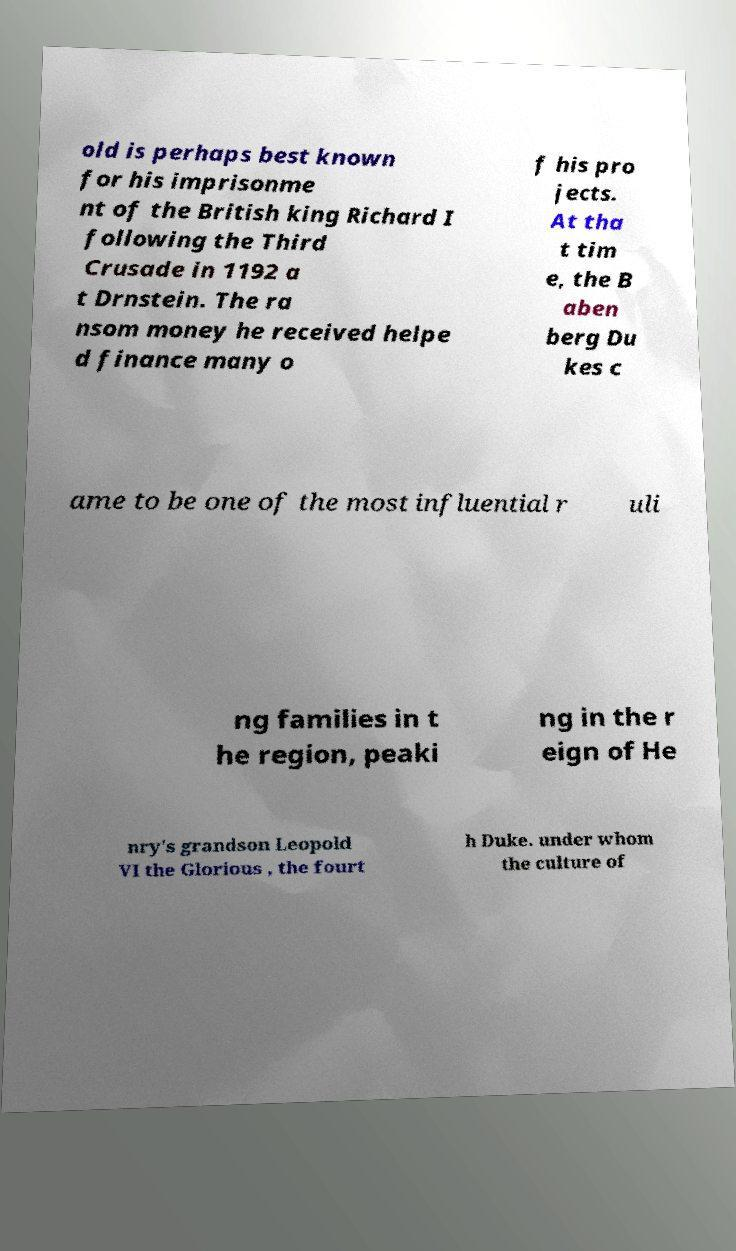There's text embedded in this image that I need extracted. Can you transcribe it verbatim? old is perhaps best known for his imprisonme nt of the British king Richard I following the Third Crusade in 1192 a t Drnstein. The ra nsom money he received helpe d finance many o f his pro jects. At tha t tim e, the B aben berg Du kes c ame to be one of the most influential r uli ng families in t he region, peaki ng in the r eign of He nry's grandson Leopold VI the Glorious , the fourt h Duke. under whom the culture of 